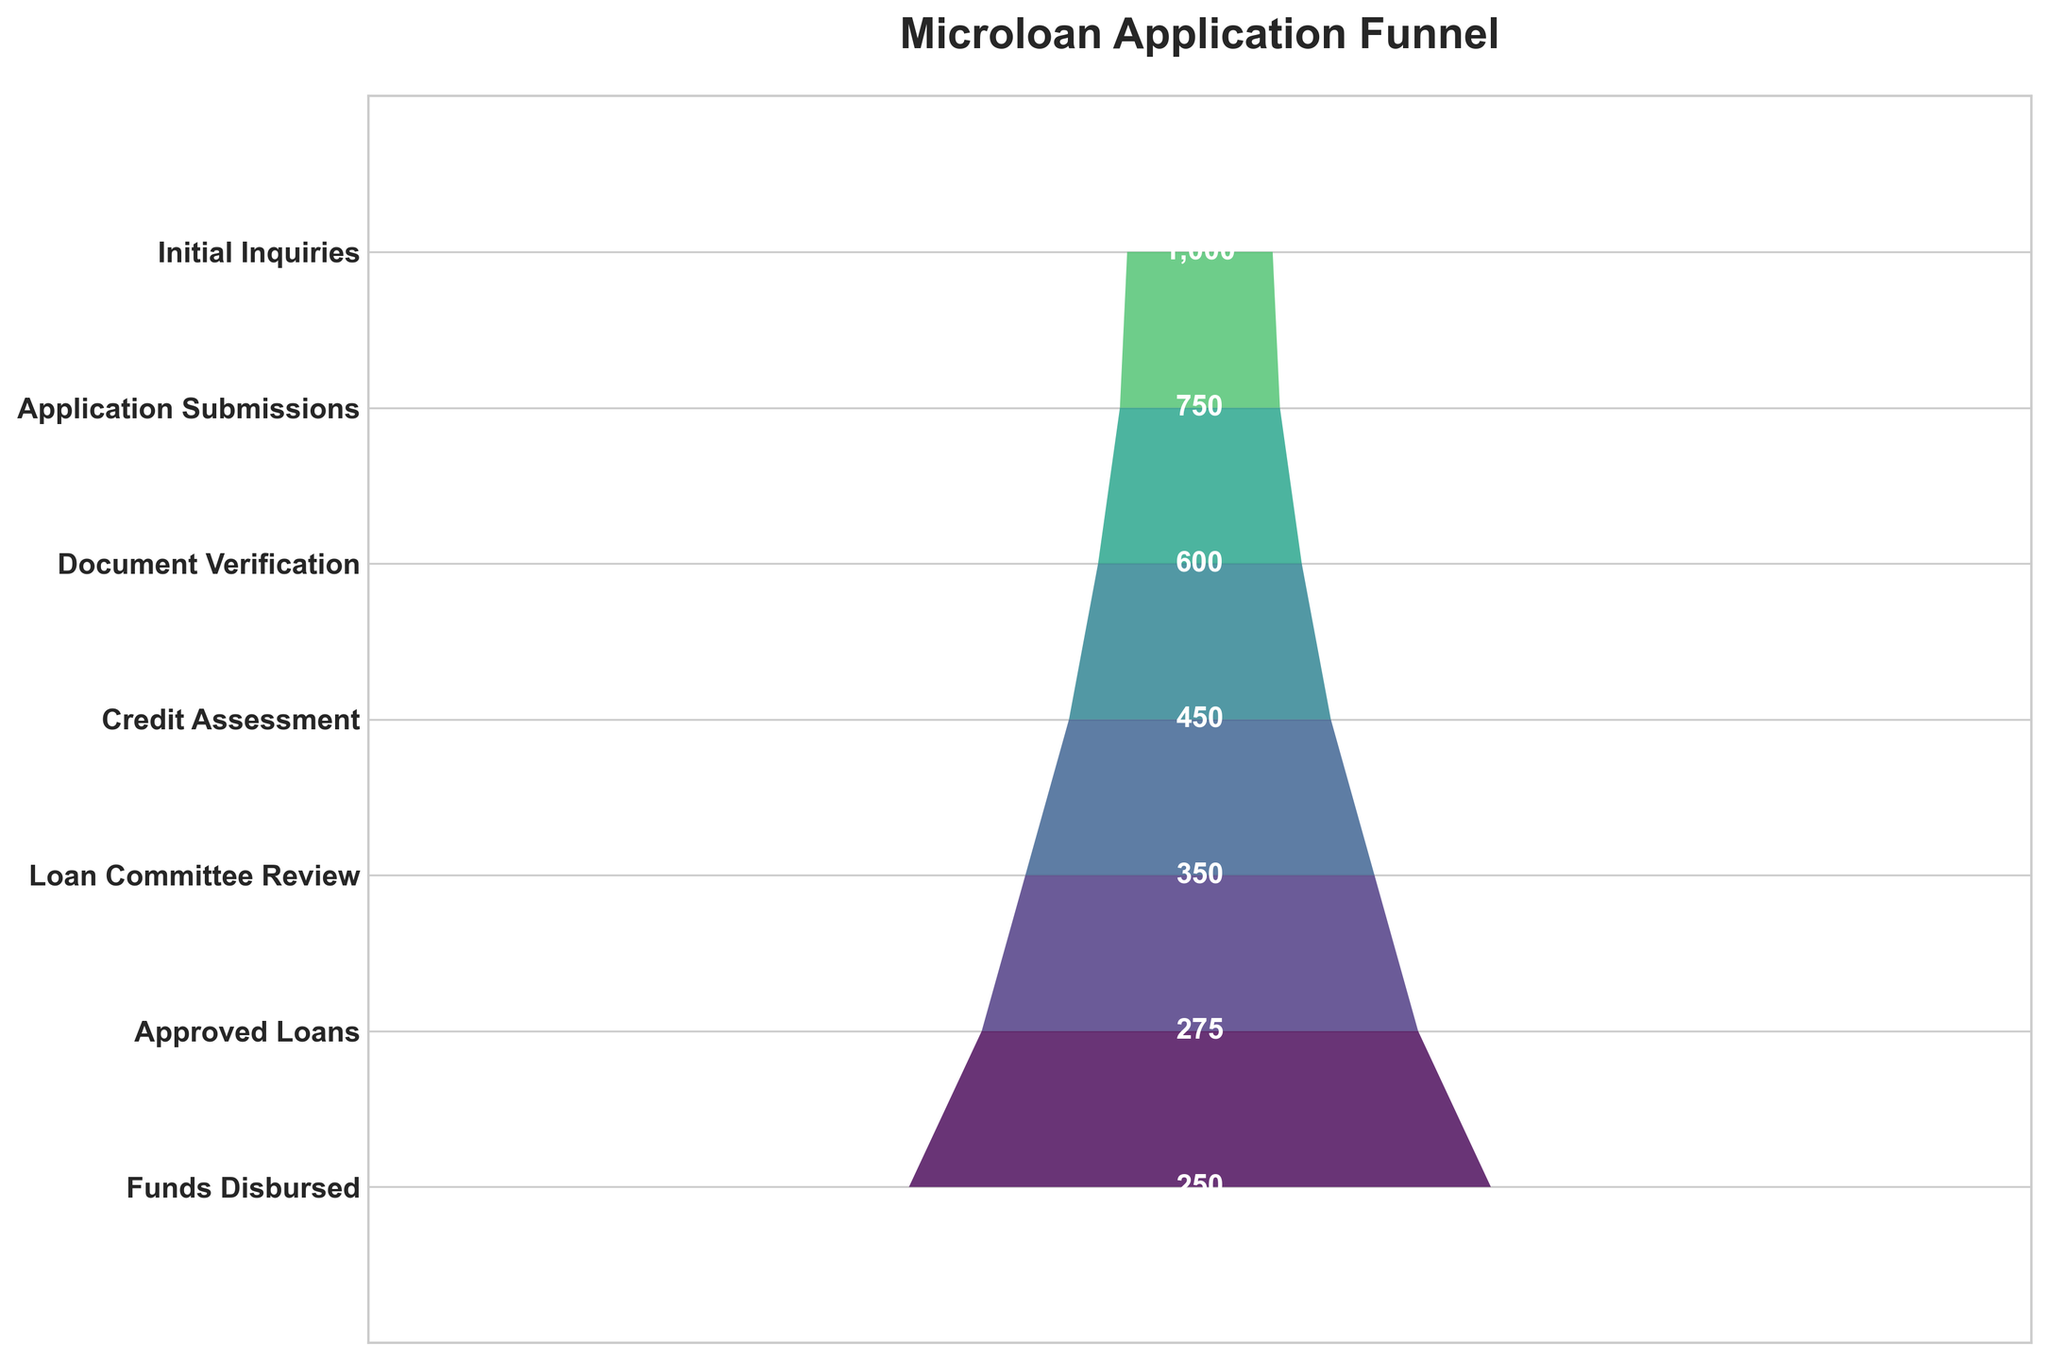what is the title of the figure? The title is at the top of the figure and is displayed prominently.
Answer: Microloan Application Funnel What is the count at the "Credit Assessment" stage? Locate the "Credit Assessment" stage on the Y-axis and read the corresponding count from the labels displayed.
Answer: 450 How many stages are shown in the funnel chart? Count the number of distinct stages listed on the Y-axis of the funnel chart.
Answer: 7 Which stage has the highest dropout between "Initial Inquiries" and "Application Submissions"? Calculate the difference in counts between the two stages and identify the one with the larger difference. The counts are 1000 and 750 respectively.
Answer: Initial Inquiries What is the total number of approved loans? Read the figure next to the "Approved Loans" stage on the Y-axis.
Answer: 275 What percentage of the "Application Submissions" progressed to "Document Verification"? Divide the count for "Document Verification" (600) by the count for "Application Submissions" (750) and multiply by 100 to get the percentage: (600/750)*100.
Answer: 80% How does the count of "Loan Committee Review" compare to the count of "Credit Assessment"? Compare the counts at both stages; look at the numbers next to the respective stages on the Y-axis. "Loan Committee Review" has 350 and "Credit Assessment" has 450.
Answer: Loan Committee Review is less than Credit Assessment What is the difference in the number of loans between "Approved Loans" and "Funds Disbursed"? Subtract the count of "Funds Disbursed" (250) from the count at "Approved Loans" (275).
Answer: 25 Between which two stages is the smallest drop-off observed? Calculate the differences between adjacent stages' counts and identify the smallest one.
Answer: Approved Loans and Funds Disbursed (275 - 250 = 25) 